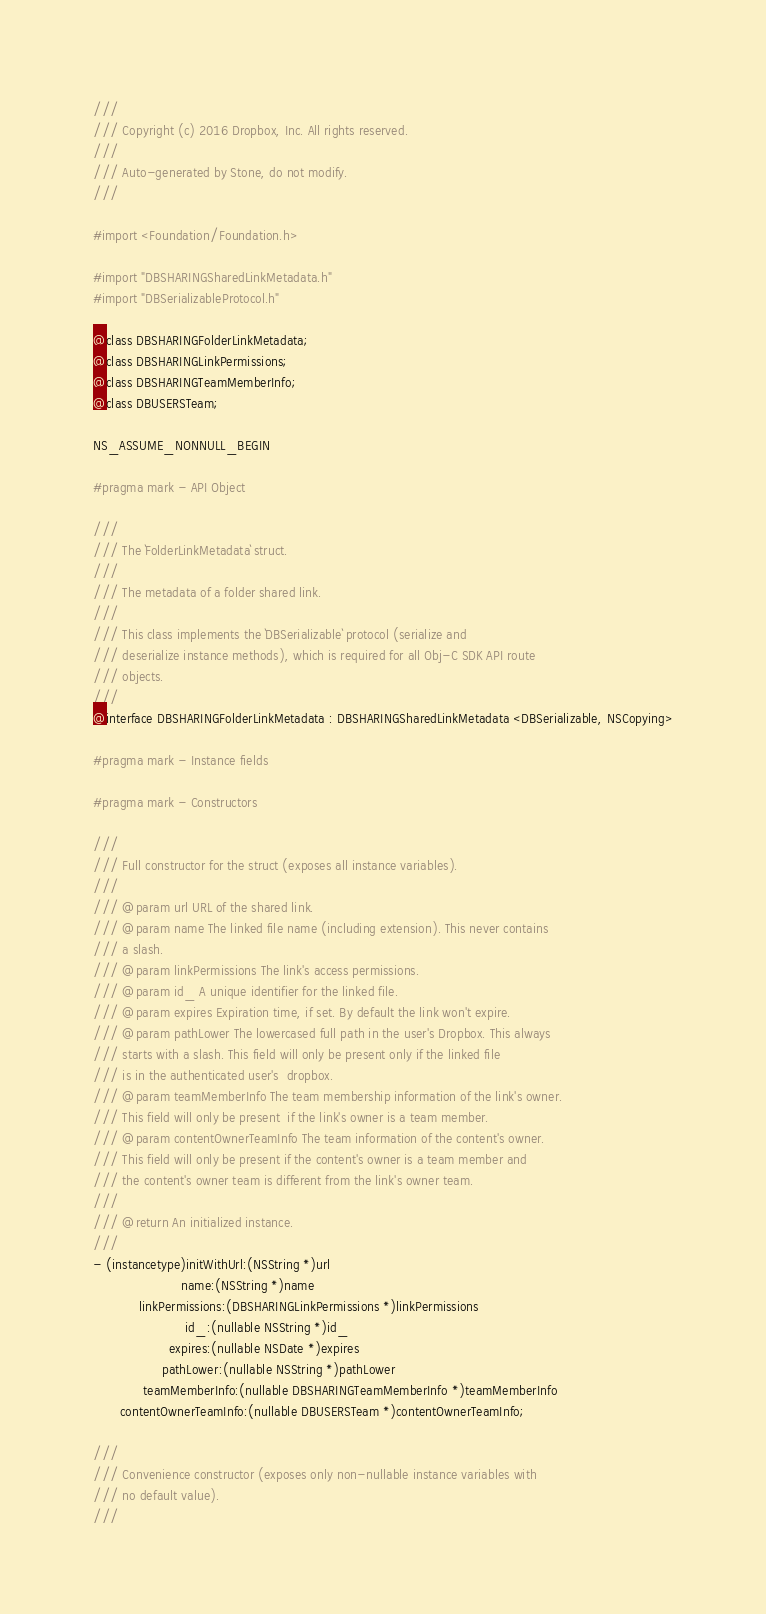Convert code to text. <code><loc_0><loc_0><loc_500><loc_500><_C_>///
/// Copyright (c) 2016 Dropbox, Inc. All rights reserved.
///
/// Auto-generated by Stone, do not modify.
///

#import <Foundation/Foundation.h>

#import "DBSHARINGSharedLinkMetadata.h"
#import "DBSerializableProtocol.h"

@class DBSHARINGFolderLinkMetadata;
@class DBSHARINGLinkPermissions;
@class DBSHARINGTeamMemberInfo;
@class DBUSERSTeam;

NS_ASSUME_NONNULL_BEGIN

#pragma mark - API Object

///
/// The `FolderLinkMetadata` struct.
///
/// The metadata of a folder shared link.
///
/// This class implements the `DBSerializable` protocol (serialize and
/// deserialize instance methods), which is required for all Obj-C SDK API route
/// objects.
///
@interface DBSHARINGFolderLinkMetadata : DBSHARINGSharedLinkMetadata <DBSerializable, NSCopying>

#pragma mark - Instance fields

#pragma mark - Constructors

///
/// Full constructor for the struct (exposes all instance variables).
///
/// @param url URL of the shared link.
/// @param name The linked file name (including extension). This never contains
/// a slash.
/// @param linkPermissions The link's access permissions.
/// @param id_ A unique identifier for the linked file.
/// @param expires Expiration time, if set. By default the link won't expire.
/// @param pathLower The lowercased full path in the user's Dropbox. This always
/// starts with a slash. This field will only be present only if the linked file
/// is in the authenticated user's  dropbox.
/// @param teamMemberInfo The team membership information of the link's owner.
/// This field will only be present  if the link's owner is a team member.
/// @param contentOwnerTeamInfo The team information of the content's owner.
/// This field will only be present if the content's owner is a team member and
/// the content's owner team is different from the link's owner team.
///
/// @return An initialized instance.
///
- (instancetype)initWithUrl:(NSString *)url
                       name:(NSString *)name
            linkPermissions:(DBSHARINGLinkPermissions *)linkPermissions
                        id_:(nullable NSString *)id_
                    expires:(nullable NSDate *)expires
                  pathLower:(nullable NSString *)pathLower
             teamMemberInfo:(nullable DBSHARINGTeamMemberInfo *)teamMemberInfo
       contentOwnerTeamInfo:(nullable DBUSERSTeam *)contentOwnerTeamInfo;

///
/// Convenience constructor (exposes only non-nullable instance variables with
/// no default value).
///</code> 